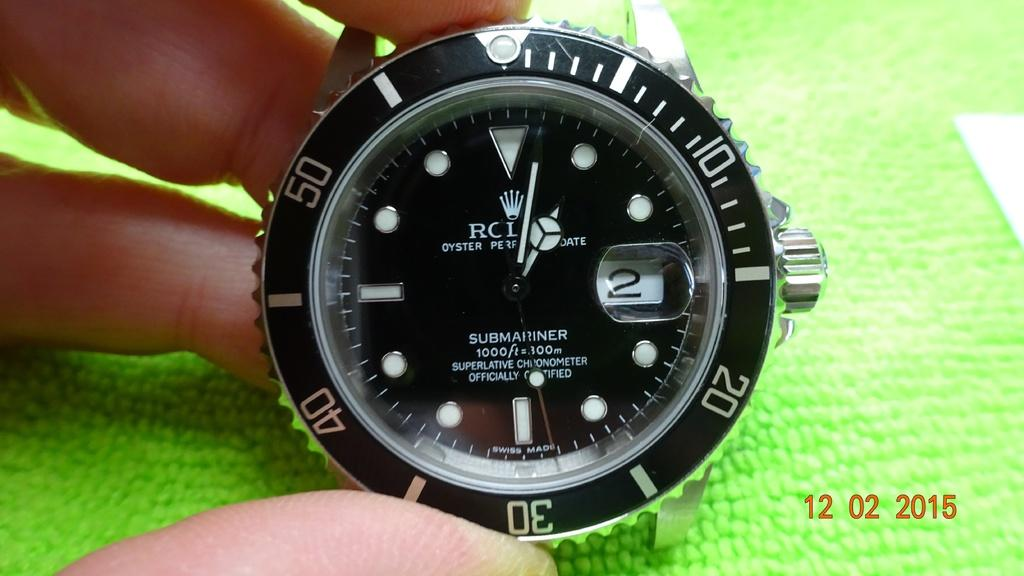<image>
Present a compact description of the photo's key features. A watch has the word submariner on the face of it. 